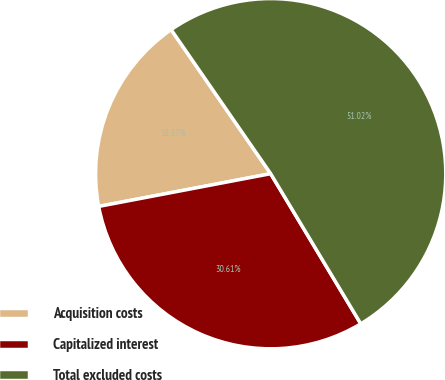<chart> <loc_0><loc_0><loc_500><loc_500><pie_chart><fcel>Acquisition costs<fcel>Capitalized interest<fcel>Total excluded costs<nl><fcel>18.37%<fcel>30.61%<fcel>51.02%<nl></chart> 